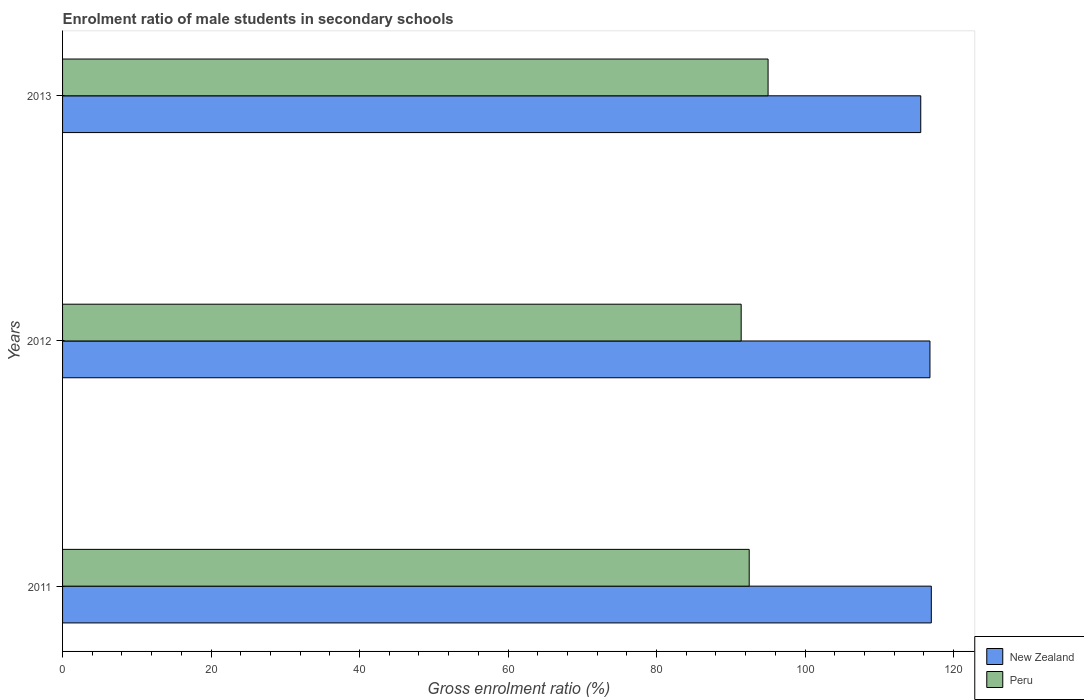How many different coloured bars are there?
Your answer should be compact. 2. Are the number of bars per tick equal to the number of legend labels?
Ensure brevity in your answer.  Yes. Are the number of bars on each tick of the Y-axis equal?
Provide a short and direct response. Yes. How many bars are there on the 3rd tick from the top?
Offer a terse response. 2. How many bars are there on the 1st tick from the bottom?
Provide a short and direct response. 2. What is the label of the 2nd group of bars from the top?
Ensure brevity in your answer.  2012. In how many cases, is the number of bars for a given year not equal to the number of legend labels?
Your answer should be very brief. 0. What is the enrolment ratio of male students in secondary schools in New Zealand in 2011?
Keep it short and to the point. 117.01. Across all years, what is the maximum enrolment ratio of male students in secondary schools in New Zealand?
Provide a short and direct response. 117.01. Across all years, what is the minimum enrolment ratio of male students in secondary schools in New Zealand?
Keep it short and to the point. 115.59. In which year was the enrolment ratio of male students in secondary schools in New Zealand maximum?
Your response must be concise. 2011. What is the total enrolment ratio of male students in secondary schools in New Zealand in the graph?
Keep it short and to the point. 349.42. What is the difference between the enrolment ratio of male students in secondary schools in Peru in 2011 and that in 2012?
Your response must be concise. 1.08. What is the difference between the enrolment ratio of male students in secondary schools in Peru in 2013 and the enrolment ratio of male students in secondary schools in New Zealand in 2012?
Your answer should be very brief. -21.8. What is the average enrolment ratio of male students in secondary schools in Peru per year?
Your answer should be very brief. 92.97. In the year 2012, what is the difference between the enrolment ratio of male students in secondary schools in New Zealand and enrolment ratio of male students in secondary schools in Peru?
Offer a very short reply. 25.43. What is the ratio of the enrolment ratio of male students in secondary schools in New Zealand in 2011 to that in 2012?
Ensure brevity in your answer.  1. What is the difference between the highest and the second highest enrolment ratio of male students in secondary schools in Peru?
Offer a terse response. 2.54. What is the difference between the highest and the lowest enrolment ratio of male students in secondary schools in Peru?
Ensure brevity in your answer.  3.62. In how many years, is the enrolment ratio of male students in secondary schools in New Zealand greater than the average enrolment ratio of male students in secondary schools in New Zealand taken over all years?
Offer a terse response. 2. What does the 2nd bar from the top in 2012 represents?
Offer a very short reply. New Zealand. What does the 2nd bar from the bottom in 2012 represents?
Provide a succinct answer. Peru. How many bars are there?
Your response must be concise. 6. What is the difference between two consecutive major ticks on the X-axis?
Offer a very short reply. 20. Are the values on the major ticks of X-axis written in scientific E-notation?
Offer a terse response. No. Does the graph contain any zero values?
Give a very brief answer. No. Where does the legend appear in the graph?
Keep it short and to the point. Bottom right. How many legend labels are there?
Your response must be concise. 2. How are the legend labels stacked?
Give a very brief answer. Vertical. What is the title of the graph?
Make the answer very short. Enrolment ratio of male students in secondary schools. Does "Sri Lanka" appear as one of the legend labels in the graph?
Make the answer very short. No. What is the label or title of the X-axis?
Make the answer very short. Gross enrolment ratio (%). What is the Gross enrolment ratio (%) of New Zealand in 2011?
Your answer should be very brief. 117.01. What is the Gross enrolment ratio (%) of Peru in 2011?
Offer a terse response. 92.48. What is the Gross enrolment ratio (%) in New Zealand in 2012?
Provide a succinct answer. 116.83. What is the Gross enrolment ratio (%) in Peru in 2012?
Offer a very short reply. 91.4. What is the Gross enrolment ratio (%) of New Zealand in 2013?
Provide a succinct answer. 115.59. What is the Gross enrolment ratio (%) in Peru in 2013?
Offer a terse response. 95.02. Across all years, what is the maximum Gross enrolment ratio (%) in New Zealand?
Provide a succinct answer. 117.01. Across all years, what is the maximum Gross enrolment ratio (%) of Peru?
Ensure brevity in your answer.  95.02. Across all years, what is the minimum Gross enrolment ratio (%) in New Zealand?
Provide a succinct answer. 115.59. Across all years, what is the minimum Gross enrolment ratio (%) of Peru?
Your answer should be compact. 91.4. What is the total Gross enrolment ratio (%) in New Zealand in the graph?
Keep it short and to the point. 349.42. What is the total Gross enrolment ratio (%) in Peru in the graph?
Your answer should be compact. 278.9. What is the difference between the Gross enrolment ratio (%) in New Zealand in 2011 and that in 2012?
Your response must be concise. 0.18. What is the difference between the Gross enrolment ratio (%) of Peru in 2011 and that in 2012?
Provide a succinct answer. 1.08. What is the difference between the Gross enrolment ratio (%) of New Zealand in 2011 and that in 2013?
Your answer should be compact. 1.42. What is the difference between the Gross enrolment ratio (%) in Peru in 2011 and that in 2013?
Keep it short and to the point. -2.54. What is the difference between the Gross enrolment ratio (%) of New Zealand in 2012 and that in 2013?
Offer a terse response. 1.24. What is the difference between the Gross enrolment ratio (%) in Peru in 2012 and that in 2013?
Give a very brief answer. -3.62. What is the difference between the Gross enrolment ratio (%) of New Zealand in 2011 and the Gross enrolment ratio (%) of Peru in 2012?
Your answer should be compact. 25.61. What is the difference between the Gross enrolment ratio (%) of New Zealand in 2011 and the Gross enrolment ratio (%) of Peru in 2013?
Provide a succinct answer. 21.99. What is the difference between the Gross enrolment ratio (%) of New Zealand in 2012 and the Gross enrolment ratio (%) of Peru in 2013?
Your answer should be compact. 21.8. What is the average Gross enrolment ratio (%) of New Zealand per year?
Keep it short and to the point. 116.47. What is the average Gross enrolment ratio (%) of Peru per year?
Ensure brevity in your answer.  92.97. In the year 2011, what is the difference between the Gross enrolment ratio (%) of New Zealand and Gross enrolment ratio (%) of Peru?
Provide a short and direct response. 24.53. In the year 2012, what is the difference between the Gross enrolment ratio (%) in New Zealand and Gross enrolment ratio (%) in Peru?
Your response must be concise. 25.43. In the year 2013, what is the difference between the Gross enrolment ratio (%) of New Zealand and Gross enrolment ratio (%) of Peru?
Ensure brevity in your answer.  20.56. What is the ratio of the Gross enrolment ratio (%) in New Zealand in 2011 to that in 2012?
Offer a terse response. 1. What is the ratio of the Gross enrolment ratio (%) of Peru in 2011 to that in 2012?
Offer a very short reply. 1.01. What is the ratio of the Gross enrolment ratio (%) of New Zealand in 2011 to that in 2013?
Your answer should be very brief. 1.01. What is the ratio of the Gross enrolment ratio (%) in Peru in 2011 to that in 2013?
Offer a very short reply. 0.97. What is the ratio of the Gross enrolment ratio (%) of New Zealand in 2012 to that in 2013?
Provide a short and direct response. 1.01. What is the ratio of the Gross enrolment ratio (%) of Peru in 2012 to that in 2013?
Provide a succinct answer. 0.96. What is the difference between the highest and the second highest Gross enrolment ratio (%) of New Zealand?
Provide a succinct answer. 0.18. What is the difference between the highest and the second highest Gross enrolment ratio (%) in Peru?
Your answer should be very brief. 2.54. What is the difference between the highest and the lowest Gross enrolment ratio (%) of New Zealand?
Ensure brevity in your answer.  1.42. What is the difference between the highest and the lowest Gross enrolment ratio (%) in Peru?
Your answer should be very brief. 3.62. 